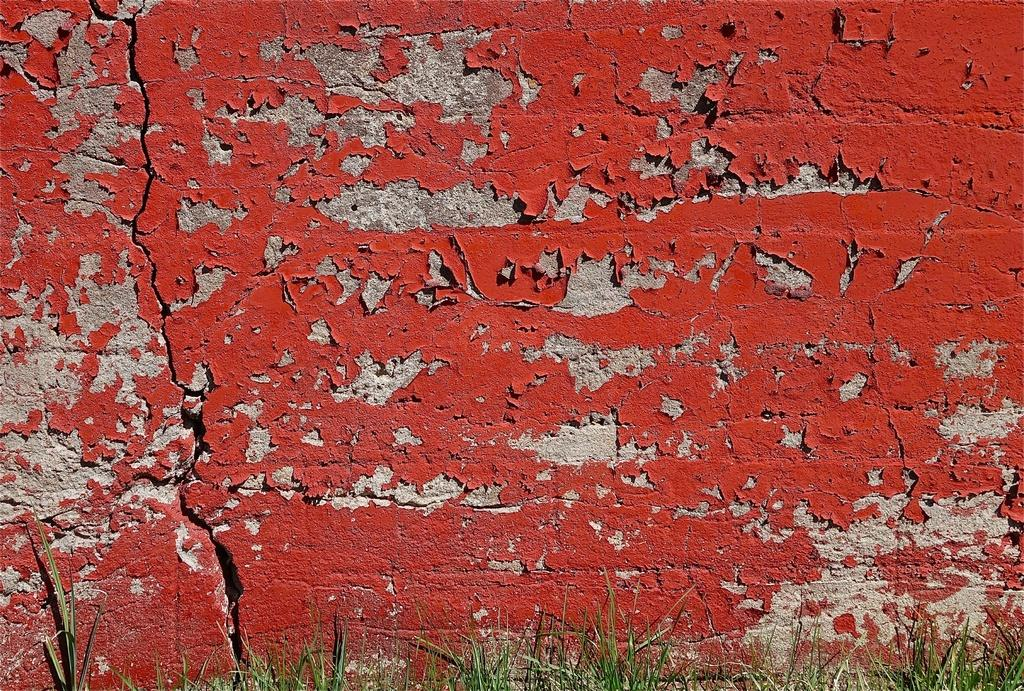What type of vegetation is present in the image? There is grass in the image. What type of structure can be seen in the image? There is a broken wall in the image. What color is the paint on the broken wall? The broken wall has red color paint on it. How many flowers can be seen growing on the broken wall in the image? There are no flowers present in the image; it only features grass and a broken wall with red paint. Can you tell me how many family members are visible in the image? There are no family members present in the image; it only features grass and a broken wall with red paint. 